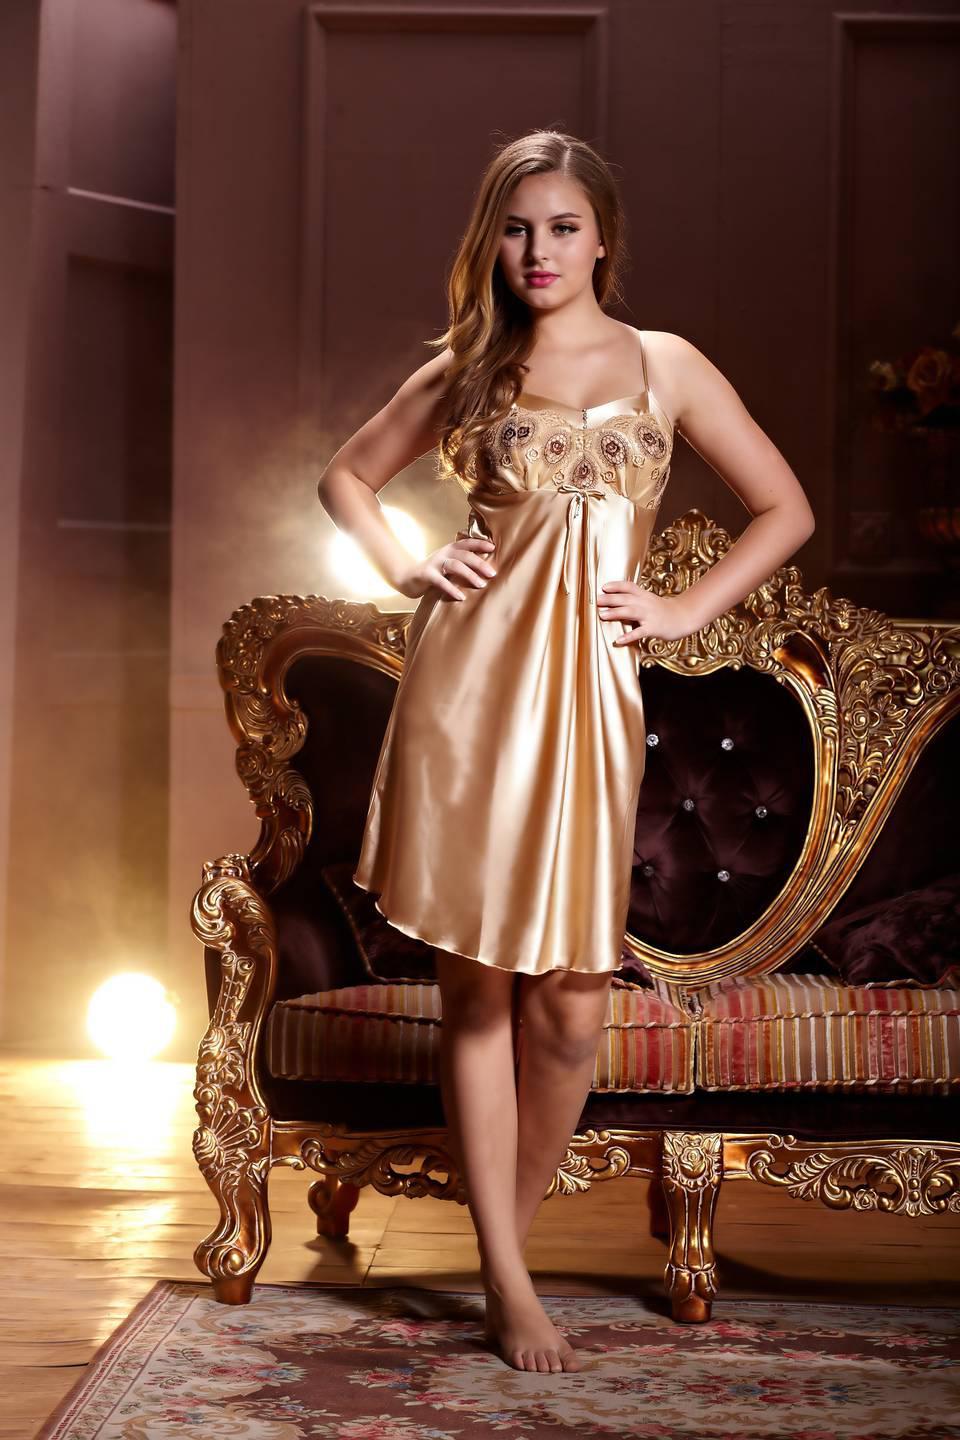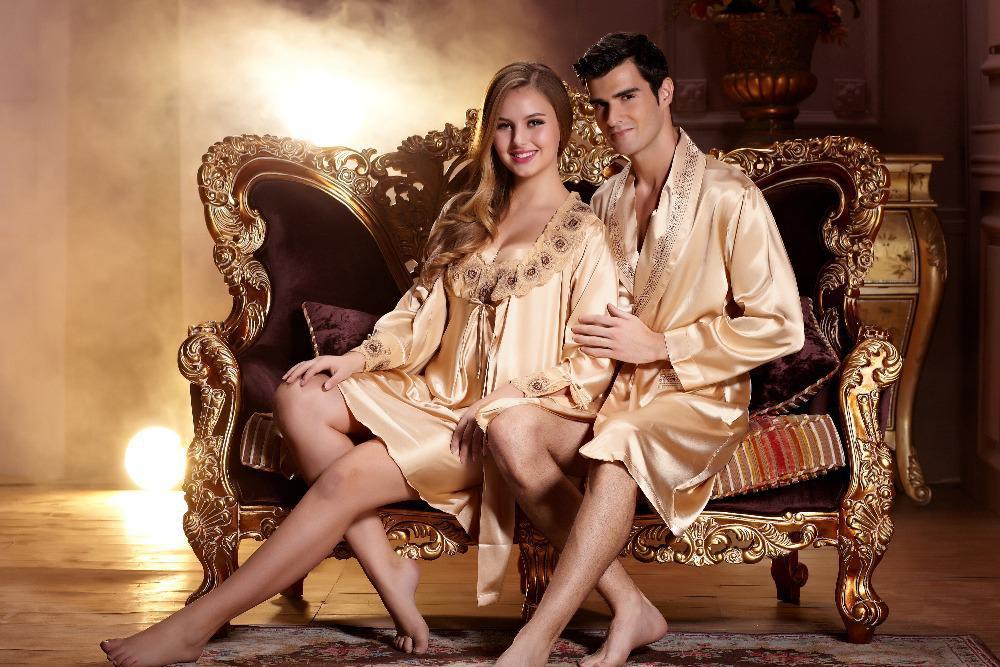The first image is the image on the left, the second image is the image on the right. Evaluate the accuracy of this statement regarding the images: "An image shows a man to the right of a woman, and both are modeling shiny loungewear.". Is it true? Answer yes or no. Yes. The first image is the image on the left, the second image is the image on the right. Evaluate the accuracy of this statement regarding the images: "A man and woman in pajamas pose near a sofa in one of the images.". Is it true? Answer yes or no. Yes. 